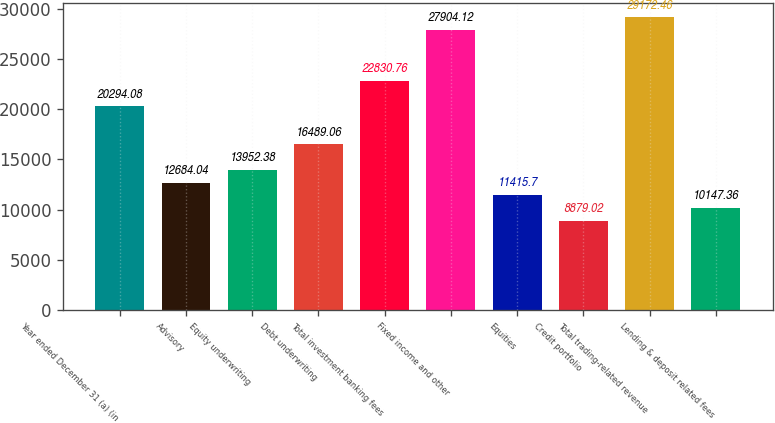<chart> <loc_0><loc_0><loc_500><loc_500><bar_chart><fcel>Year ended December 31 (a) (in<fcel>Advisory<fcel>Equity underwriting<fcel>Debt underwriting<fcel>Total investment banking fees<fcel>Fixed income and other<fcel>Equities<fcel>Credit portfolio<fcel>Total trading-related revenue<fcel>Lending & deposit related fees<nl><fcel>20294.1<fcel>12684<fcel>13952.4<fcel>16489.1<fcel>22830.8<fcel>27904.1<fcel>11415.7<fcel>8879.02<fcel>29172.5<fcel>10147.4<nl></chart> 